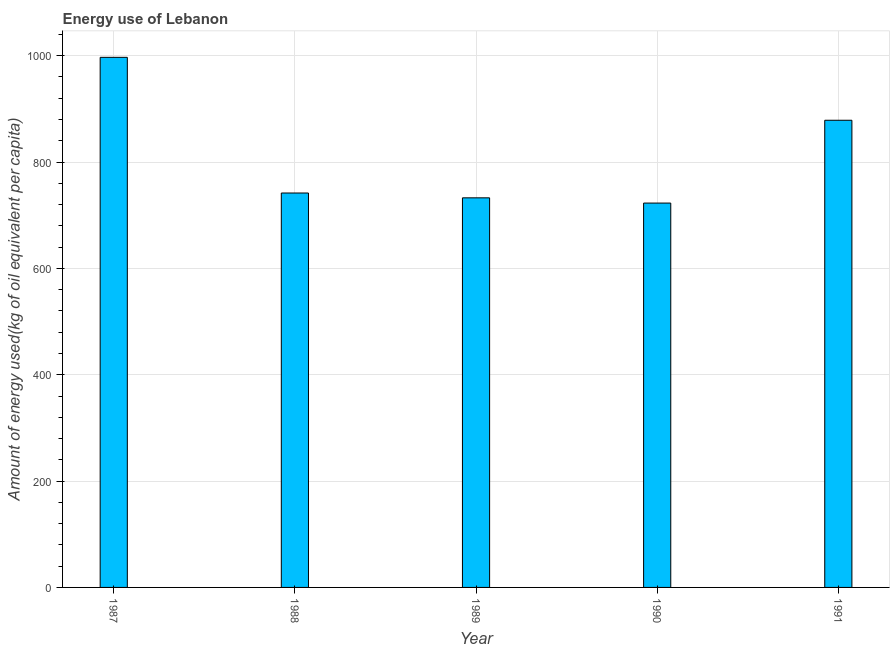What is the title of the graph?
Offer a terse response. Energy use of Lebanon. What is the label or title of the X-axis?
Offer a very short reply. Year. What is the label or title of the Y-axis?
Keep it short and to the point. Amount of energy used(kg of oil equivalent per capita). What is the amount of energy used in 1991?
Offer a terse response. 878.6. Across all years, what is the maximum amount of energy used?
Keep it short and to the point. 996.94. Across all years, what is the minimum amount of energy used?
Provide a succinct answer. 722.86. In which year was the amount of energy used maximum?
Provide a short and direct response. 1987. What is the sum of the amount of energy used?
Your response must be concise. 4072.86. What is the difference between the amount of energy used in 1987 and 1991?
Your answer should be very brief. 118.34. What is the average amount of energy used per year?
Your answer should be compact. 814.57. What is the median amount of energy used?
Give a very brief answer. 741.76. Do a majority of the years between 1991 and 1989 (inclusive) have amount of energy used greater than 760 kg?
Your response must be concise. Yes. What is the ratio of the amount of energy used in 1987 to that in 1989?
Keep it short and to the point. 1.36. Is the difference between the amount of energy used in 1987 and 1988 greater than the difference between any two years?
Keep it short and to the point. No. What is the difference between the highest and the second highest amount of energy used?
Offer a terse response. 118.34. What is the difference between the highest and the lowest amount of energy used?
Offer a very short reply. 274.09. How many bars are there?
Ensure brevity in your answer.  5. How many years are there in the graph?
Your answer should be very brief. 5. Are the values on the major ticks of Y-axis written in scientific E-notation?
Your answer should be very brief. No. What is the Amount of energy used(kg of oil equivalent per capita) of 1987?
Offer a terse response. 996.94. What is the Amount of energy used(kg of oil equivalent per capita) of 1988?
Make the answer very short. 741.76. What is the Amount of energy used(kg of oil equivalent per capita) in 1989?
Offer a terse response. 732.69. What is the Amount of energy used(kg of oil equivalent per capita) in 1990?
Provide a short and direct response. 722.86. What is the Amount of energy used(kg of oil equivalent per capita) in 1991?
Keep it short and to the point. 878.6. What is the difference between the Amount of energy used(kg of oil equivalent per capita) in 1987 and 1988?
Give a very brief answer. 255.18. What is the difference between the Amount of energy used(kg of oil equivalent per capita) in 1987 and 1989?
Keep it short and to the point. 264.25. What is the difference between the Amount of energy used(kg of oil equivalent per capita) in 1987 and 1990?
Make the answer very short. 274.09. What is the difference between the Amount of energy used(kg of oil equivalent per capita) in 1987 and 1991?
Your answer should be compact. 118.34. What is the difference between the Amount of energy used(kg of oil equivalent per capita) in 1988 and 1989?
Provide a succinct answer. 9.07. What is the difference between the Amount of energy used(kg of oil equivalent per capita) in 1988 and 1990?
Offer a terse response. 18.91. What is the difference between the Amount of energy used(kg of oil equivalent per capita) in 1988 and 1991?
Offer a very short reply. -136.84. What is the difference between the Amount of energy used(kg of oil equivalent per capita) in 1989 and 1990?
Your answer should be very brief. 9.83. What is the difference between the Amount of energy used(kg of oil equivalent per capita) in 1989 and 1991?
Ensure brevity in your answer.  -145.91. What is the difference between the Amount of energy used(kg of oil equivalent per capita) in 1990 and 1991?
Keep it short and to the point. -155.75. What is the ratio of the Amount of energy used(kg of oil equivalent per capita) in 1987 to that in 1988?
Your answer should be very brief. 1.34. What is the ratio of the Amount of energy used(kg of oil equivalent per capita) in 1987 to that in 1989?
Offer a terse response. 1.36. What is the ratio of the Amount of energy used(kg of oil equivalent per capita) in 1987 to that in 1990?
Offer a terse response. 1.38. What is the ratio of the Amount of energy used(kg of oil equivalent per capita) in 1987 to that in 1991?
Offer a very short reply. 1.14. What is the ratio of the Amount of energy used(kg of oil equivalent per capita) in 1988 to that in 1989?
Your answer should be very brief. 1.01. What is the ratio of the Amount of energy used(kg of oil equivalent per capita) in 1988 to that in 1990?
Provide a succinct answer. 1.03. What is the ratio of the Amount of energy used(kg of oil equivalent per capita) in 1988 to that in 1991?
Keep it short and to the point. 0.84. What is the ratio of the Amount of energy used(kg of oil equivalent per capita) in 1989 to that in 1991?
Your answer should be compact. 0.83. What is the ratio of the Amount of energy used(kg of oil equivalent per capita) in 1990 to that in 1991?
Make the answer very short. 0.82. 